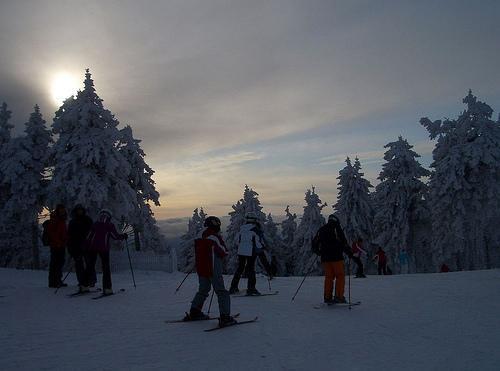How many types of transportation items are in this picture?
Give a very brief answer. 1. 